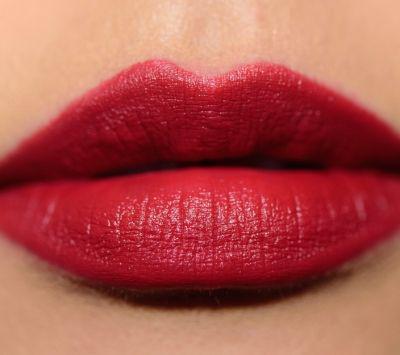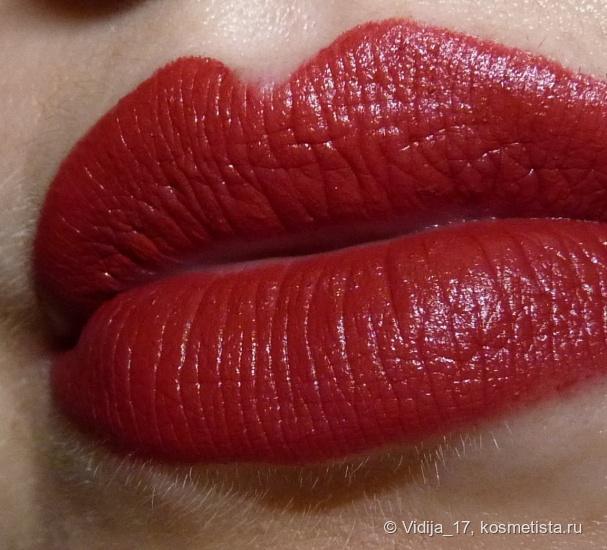The first image is the image on the left, the second image is the image on the right. For the images shown, is this caption "One image includes a lip makeup item and at least one pair of tinted lips, and the other image contains at least one pair of tinted lips but no lip makeup item." true? Answer yes or no. No. The first image is the image on the left, the second image is the image on the right. Assess this claim about the two images: "A single pair of lips is wearing lipstick in each of the images.". Correct or not? Answer yes or no. Yes. 